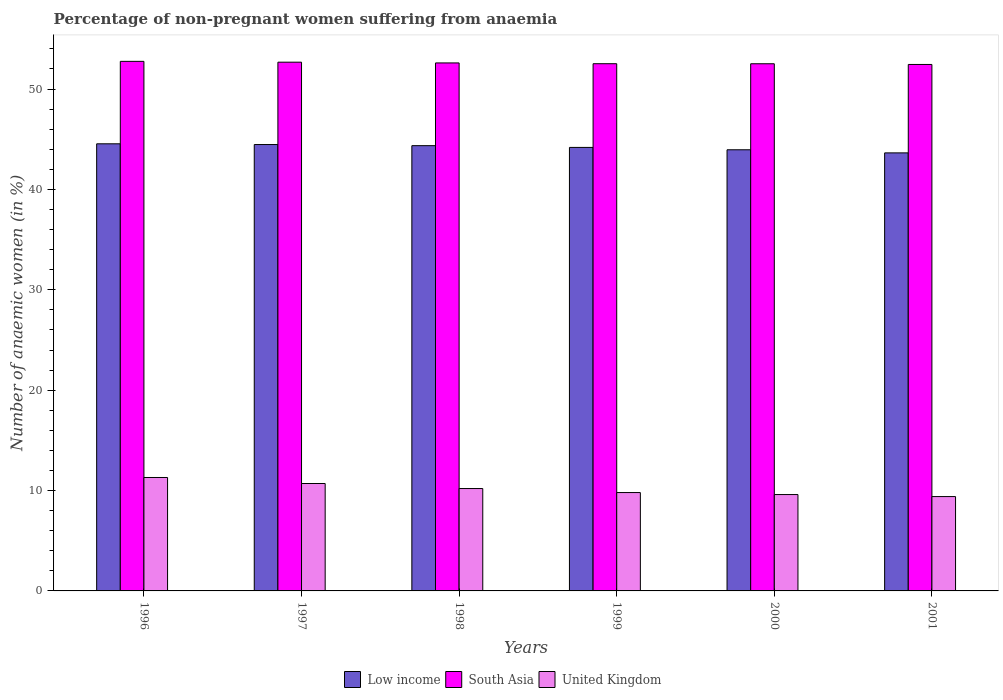How many different coloured bars are there?
Ensure brevity in your answer.  3. Are the number of bars per tick equal to the number of legend labels?
Offer a very short reply. Yes. How many bars are there on the 5th tick from the left?
Give a very brief answer. 3. What is the percentage of non-pregnant women suffering from anaemia in United Kingdom in 1996?
Offer a terse response. 11.3. Across all years, what is the maximum percentage of non-pregnant women suffering from anaemia in South Asia?
Your response must be concise. 52.76. In which year was the percentage of non-pregnant women suffering from anaemia in Low income minimum?
Make the answer very short. 2001. What is the difference between the percentage of non-pregnant women suffering from anaemia in South Asia in 1996 and that in 2001?
Offer a very short reply. 0.31. What is the difference between the percentage of non-pregnant women suffering from anaemia in Low income in 2000 and the percentage of non-pregnant women suffering from anaemia in United Kingdom in 2001?
Your answer should be compact. 34.55. What is the average percentage of non-pregnant women suffering from anaemia in Low income per year?
Provide a succinct answer. 44.19. In the year 1999, what is the difference between the percentage of non-pregnant women suffering from anaemia in Low income and percentage of non-pregnant women suffering from anaemia in South Asia?
Offer a very short reply. -8.34. In how many years, is the percentage of non-pregnant women suffering from anaemia in United Kingdom greater than 6 %?
Keep it short and to the point. 6. What is the ratio of the percentage of non-pregnant women suffering from anaemia in South Asia in 1997 to that in 2001?
Make the answer very short. 1. Is the percentage of non-pregnant women suffering from anaemia in United Kingdom in 1997 less than that in 1998?
Offer a very short reply. No. Is the difference between the percentage of non-pregnant women suffering from anaemia in Low income in 1997 and 1998 greater than the difference between the percentage of non-pregnant women suffering from anaemia in South Asia in 1997 and 1998?
Make the answer very short. Yes. What is the difference between the highest and the second highest percentage of non-pregnant women suffering from anaemia in South Asia?
Keep it short and to the point. 0.08. What is the difference between the highest and the lowest percentage of non-pregnant women suffering from anaemia in South Asia?
Your response must be concise. 0.31. In how many years, is the percentage of non-pregnant women suffering from anaemia in Low income greater than the average percentage of non-pregnant women suffering from anaemia in Low income taken over all years?
Your answer should be very brief. 3. Is the sum of the percentage of non-pregnant women suffering from anaemia in Low income in 1997 and 2000 greater than the maximum percentage of non-pregnant women suffering from anaemia in United Kingdom across all years?
Your response must be concise. Yes. Are all the bars in the graph horizontal?
Provide a short and direct response. No. Are the values on the major ticks of Y-axis written in scientific E-notation?
Your answer should be very brief. No. Does the graph contain any zero values?
Your response must be concise. No. How many legend labels are there?
Provide a succinct answer. 3. How are the legend labels stacked?
Your response must be concise. Horizontal. What is the title of the graph?
Offer a terse response. Percentage of non-pregnant women suffering from anaemia. Does "Ghana" appear as one of the legend labels in the graph?
Offer a very short reply. No. What is the label or title of the X-axis?
Ensure brevity in your answer.  Years. What is the label or title of the Y-axis?
Provide a succinct answer. Number of anaemic women (in %). What is the Number of anaemic women (in %) in Low income in 1996?
Your answer should be very brief. 44.54. What is the Number of anaemic women (in %) of South Asia in 1996?
Your response must be concise. 52.76. What is the Number of anaemic women (in %) of Low income in 1997?
Keep it short and to the point. 44.47. What is the Number of anaemic women (in %) of South Asia in 1997?
Your answer should be compact. 52.67. What is the Number of anaemic women (in %) of Low income in 1998?
Offer a terse response. 44.36. What is the Number of anaemic women (in %) in South Asia in 1998?
Keep it short and to the point. 52.6. What is the Number of anaemic women (in %) in United Kingdom in 1998?
Keep it short and to the point. 10.2. What is the Number of anaemic women (in %) in Low income in 1999?
Provide a short and direct response. 44.18. What is the Number of anaemic women (in %) in South Asia in 1999?
Ensure brevity in your answer.  52.52. What is the Number of anaemic women (in %) in United Kingdom in 1999?
Your answer should be compact. 9.8. What is the Number of anaemic women (in %) of Low income in 2000?
Your response must be concise. 43.95. What is the Number of anaemic women (in %) of South Asia in 2000?
Your answer should be compact. 52.52. What is the Number of anaemic women (in %) in United Kingdom in 2000?
Provide a succinct answer. 9.6. What is the Number of anaemic women (in %) of Low income in 2001?
Keep it short and to the point. 43.64. What is the Number of anaemic women (in %) in South Asia in 2001?
Your response must be concise. 52.45. What is the Number of anaemic women (in %) of United Kingdom in 2001?
Your response must be concise. 9.4. Across all years, what is the maximum Number of anaemic women (in %) of Low income?
Your answer should be very brief. 44.54. Across all years, what is the maximum Number of anaemic women (in %) of South Asia?
Provide a short and direct response. 52.76. Across all years, what is the minimum Number of anaemic women (in %) of Low income?
Your answer should be very brief. 43.64. Across all years, what is the minimum Number of anaemic women (in %) in South Asia?
Your answer should be very brief. 52.45. Across all years, what is the minimum Number of anaemic women (in %) of United Kingdom?
Ensure brevity in your answer.  9.4. What is the total Number of anaemic women (in %) in Low income in the graph?
Keep it short and to the point. 265.14. What is the total Number of anaemic women (in %) in South Asia in the graph?
Your answer should be very brief. 315.51. What is the total Number of anaemic women (in %) of United Kingdom in the graph?
Provide a short and direct response. 61. What is the difference between the Number of anaemic women (in %) of Low income in 1996 and that in 1997?
Provide a succinct answer. 0.07. What is the difference between the Number of anaemic women (in %) of South Asia in 1996 and that in 1997?
Keep it short and to the point. 0.08. What is the difference between the Number of anaemic women (in %) of Low income in 1996 and that in 1998?
Make the answer very short. 0.18. What is the difference between the Number of anaemic women (in %) in South Asia in 1996 and that in 1998?
Provide a short and direct response. 0.16. What is the difference between the Number of anaemic women (in %) of Low income in 1996 and that in 1999?
Your answer should be compact. 0.36. What is the difference between the Number of anaemic women (in %) of South Asia in 1996 and that in 1999?
Provide a short and direct response. 0.24. What is the difference between the Number of anaemic women (in %) in Low income in 1996 and that in 2000?
Make the answer very short. 0.59. What is the difference between the Number of anaemic women (in %) in South Asia in 1996 and that in 2000?
Offer a terse response. 0.24. What is the difference between the Number of anaemic women (in %) in Low income in 1996 and that in 2001?
Ensure brevity in your answer.  0.9. What is the difference between the Number of anaemic women (in %) of South Asia in 1996 and that in 2001?
Provide a short and direct response. 0.31. What is the difference between the Number of anaemic women (in %) in Low income in 1997 and that in 1998?
Your answer should be very brief. 0.11. What is the difference between the Number of anaemic women (in %) of South Asia in 1997 and that in 1998?
Provide a short and direct response. 0.07. What is the difference between the Number of anaemic women (in %) of United Kingdom in 1997 and that in 1998?
Provide a short and direct response. 0.5. What is the difference between the Number of anaemic women (in %) in Low income in 1997 and that in 1999?
Offer a terse response. 0.29. What is the difference between the Number of anaemic women (in %) in South Asia in 1997 and that in 1999?
Your answer should be very brief. 0.15. What is the difference between the Number of anaemic women (in %) of United Kingdom in 1997 and that in 1999?
Ensure brevity in your answer.  0.9. What is the difference between the Number of anaemic women (in %) in Low income in 1997 and that in 2000?
Ensure brevity in your answer.  0.52. What is the difference between the Number of anaemic women (in %) in South Asia in 1997 and that in 2000?
Provide a succinct answer. 0.16. What is the difference between the Number of anaemic women (in %) in Low income in 1997 and that in 2001?
Your answer should be very brief. 0.83. What is the difference between the Number of anaemic women (in %) in South Asia in 1997 and that in 2001?
Give a very brief answer. 0.23. What is the difference between the Number of anaemic women (in %) of Low income in 1998 and that in 1999?
Give a very brief answer. 0.17. What is the difference between the Number of anaemic women (in %) of South Asia in 1998 and that in 1999?
Ensure brevity in your answer.  0.08. What is the difference between the Number of anaemic women (in %) in Low income in 1998 and that in 2000?
Your answer should be compact. 0.41. What is the difference between the Number of anaemic women (in %) of South Asia in 1998 and that in 2000?
Give a very brief answer. 0.08. What is the difference between the Number of anaemic women (in %) in United Kingdom in 1998 and that in 2000?
Your response must be concise. 0.6. What is the difference between the Number of anaemic women (in %) of Low income in 1998 and that in 2001?
Your answer should be compact. 0.72. What is the difference between the Number of anaemic women (in %) of South Asia in 1998 and that in 2001?
Keep it short and to the point. 0.15. What is the difference between the Number of anaemic women (in %) in United Kingdom in 1998 and that in 2001?
Ensure brevity in your answer.  0.8. What is the difference between the Number of anaemic women (in %) of Low income in 1999 and that in 2000?
Offer a terse response. 0.24. What is the difference between the Number of anaemic women (in %) of South Asia in 1999 and that in 2000?
Your answer should be compact. 0. What is the difference between the Number of anaemic women (in %) of United Kingdom in 1999 and that in 2000?
Provide a short and direct response. 0.2. What is the difference between the Number of anaemic women (in %) of Low income in 1999 and that in 2001?
Your answer should be very brief. 0.54. What is the difference between the Number of anaemic women (in %) in South Asia in 1999 and that in 2001?
Provide a succinct answer. 0.07. What is the difference between the Number of anaemic women (in %) of United Kingdom in 1999 and that in 2001?
Provide a succinct answer. 0.4. What is the difference between the Number of anaemic women (in %) of Low income in 2000 and that in 2001?
Offer a terse response. 0.31. What is the difference between the Number of anaemic women (in %) of South Asia in 2000 and that in 2001?
Your answer should be compact. 0.07. What is the difference between the Number of anaemic women (in %) of United Kingdom in 2000 and that in 2001?
Ensure brevity in your answer.  0.2. What is the difference between the Number of anaemic women (in %) in Low income in 1996 and the Number of anaemic women (in %) in South Asia in 1997?
Make the answer very short. -8.13. What is the difference between the Number of anaemic women (in %) of Low income in 1996 and the Number of anaemic women (in %) of United Kingdom in 1997?
Your response must be concise. 33.84. What is the difference between the Number of anaemic women (in %) of South Asia in 1996 and the Number of anaemic women (in %) of United Kingdom in 1997?
Provide a succinct answer. 42.06. What is the difference between the Number of anaemic women (in %) in Low income in 1996 and the Number of anaemic women (in %) in South Asia in 1998?
Give a very brief answer. -8.06. What is the difference between the Number of anaemic women (in %) in Low income in 1996 and the Number of anaemic women (in %) in United Kingdom in 1998?
Keep it short and to the point. 34.34. What is the difference between the Number of anaemic women (in %) in South Asia in 1996 and the Number of anaemic women (in %) in United Kingdom in 1998?
Offer a very short reply. 42.56. What is the difference between the Number of anaemic women (in %) in Low income in 1996 and the Number of anaemic women (in %) in South Asia in 1999?
Offer a very short reply. -7.98. What is the difference between the Number of anaemic women (in %) in Low income in 1996 and the Number of anaemic women (in %) in United Kingdom in 1999?
Ensure brevity in your answer.  34.74. What is the difference between the Number of anaemic women (in %) of South Asia in 1996 and the Number of anaemic women (in %) of United Kingdom in 1999?
Provide a short and direct response. 42.96. What is the difference between the Number of anaemic women (in %) of Low income in 1996 and the Number of anaemic women (in %) of South Asia in 2000?
Provide a succinct answer. -7.97. What is the difference between the Number of anaemic women (in %) of Low income in 1996 and the Number of anaemic women (in %) of United Kingdom in 2000?
Give a very brief answer. 34.94. What is the difference between the Number of anaemic women (in %) in South Asia in 1996 and the Number of anaemic women (in %) in United Kingdom in 2000?
Provide a succinct answer. 43.16. What is the difference between the Number of anaemic women (in %) in Low income in 1996 and the Number of anaemic women (in %) in South Asia in 2001?
Your answer should be very brief. -7.9. What is the difference between the Number of anaemic women (in %) in Low income in 1996 and the Number of anaemic women (in %) in United Kingdom in 2001?
Keep it short and to the point. 35.14. What is the difference between the Number of anaemic women (in %) in South Asia in 1996 and the Number of anaemic women (in %) in United Kingdom in 2001?
Make the answer very short. 43.36. What is the difference between the Number of anaemic women (in %) in Low income in 1997 and the Number of anaemic women (in %) in South Asia in 1998?
Offer a terse response. -8.13. What is the difference between the Number of anaemic women (in %) of Low income in 1997 and the Number of anaemic women (in %) of United Kingdom in 1998?
Your answer should be very brief. 34.27. What is the difference between the Number of anaemic women (in %) of South Asia in 1997 and the Number of anaemic women (in %) of United Kingdom in 1998?
Offer a terse response. 42.47. What is the difference between the Number of anaemic women (in %) in Low income in 1997 and the Number of anaemic women (in %) in South Asia in 1999?
Offer a terse response. -8.05. What is the difference between the Number of anaemic women (in %) in Low income in 1997 and the Number of anaemic women (in %) in United Kingdom in 1999?
Your response must be concise. 34.67. What is the difference between the Number of anaemic women (in %) of South Asia in 1997 and the Number of anaemic women (in %) of United Kingdom in 1999?
Provide a succinct answer. 42.87. What is the difference between the Number of anaemic women (in %) of Low income in 1997 and the Number of anaemic women (in %) of South Asia in 2000?
Give a very brief answer. -8.05. What is the difference between the Number of anaemic women (in %) in Low income in 1997 and the Number of anaemic women (in %) in United Kingdom in 2000?
Give a very brief answer. 34.87. What is the difference between the Number of anaemic women (in %) in South Asia in 1997 and the Number of anaemic women (in %) in United Kingdom in 2000?
Your answer should be very brief. 43.07. What is the difference between the Number of anaemic women (in %) in Low income in 1997 and the Number of anaemic women (in %) in South Asia in 2001?
Ensure brevity in your answer.  -7.98. What is the difference between the Number of anaemic women (in %) of Low income in 1997 and the Number of anaemic women (in %) of United Kingdom in 2001?
Provide a succinct answer. 35.07. What is the difference between the Number of anaemic women (in %) in South Asia in 1997 and the Number of anaemic women (in %) in United Kingdom in 2001?
Provide a short and direct response. 43.27. What is the difference between the Number of anaemic women (in %) of Low income in 1998 and the Number of anaemic women (in %) of South Asia in 1999?
Offer a terse response. -8.16. What is the difference between the Number of anaemic women (in %) in Low income in 1998 and the Number of anaemic women (in %) in United Kingdom in 1999?
Offer a terse response. 34.56. What is the difference between the Number of anaemic women (in %) in South Asia in 1998 and the Number of anaemic women (in %) in United Kingdom in 1999?
Keep it short and to the point. 42.8. What is the difference between the Number of anaemic women (in %) in Low income in 1998 and the Number of anaemic women (in %) in South Asia in 2000?
Keep it short and to the point. -8.16. What is the difference between the Number of anaemic women (in %) in Low income in 1998 and the Number of anaemic women (in %) in United Kingdom in 2000?
Your response must be concise. 34.76. What is the difference between the Number of anaemic women (in %) in South Asia in 1998 and the Number of anaemic women (in %) in United Kingdom in 2000?
Provide a succinct answer. 43. What is the difference between the Number of anaemic women (in %) of Low income in 1998 and the Number of anaemic women (in %) of South Asia in 2001?
Keep it short and to the point. -8.09. What is the difference between the Number of anaemic women (in %) of Low income in 1998 and the Number of anaemic women (in %) of United Kingdom in 2001?
Give a very brief answer. 34.96. What is the difference between the Number of anaemic women (in %) in South Asia in 1998 and the Number of anaemic women (in %) in United Kingdom in 2001?
Provide a succinct answer. 43.2. What is the difference between the Number of anaemic women (in %) of Low income in 1999 and the Number of anaemic women (in %) of South Asia in 2000?
Ensure brevity in your answer.  -8.33. What is the difference between the Number of anaemic women (in %) of Low income in 1999 and the Number of anaemic women (in %) of United Kingdom in 2000?
Provide a short and direct response. 34.58. What is the difference between the Number of anaemic women (in %) in South Asia in 1999 and the Number of anaemic women (in %) in United Kingdom in 2000?
Keep it short and to the point. 42.92. What is the difference between the Number of anaemic women (in %) of Low income in 1999 and the Number of anaemic women (in %) of South Asia in 2001?
Give a very brief answer. -8.26. What is the difference between the Number of anaemic women (in %) of Low income in 1999 and the Number of anaemic women (in %) of United Kingdom in 2001?
Keep it short and to the point. 34.78. What is the difference between the Number of anaemic women (in %) in South Asia in 1999 and the Number of anaemic women (in %) in United Kingdom in 2001?
Give a very brief answer. 43.12. What is the difference between the Number of anaemic women (in %) in Low income in 2000 and the Number of anaemic women (in %) in South Asia in 2001?
Ensure brevity in your answer.  -8.5. What is the difference between the Number of anaemic women (in %) of Low income in 2000 and the Number of anaemic women (in %) of United Kingdom in 2001?
Offer a very short reply. 34.55. What is the difference between the Number of anaemic women (in %) of South Asia in 2000 and the Number of anaemic women (in %) of United Kingdom in 2001?
Provide a short and direct response. 43.12. What is the average Number of anaemic women (in %) in Low income per year?
Offer a very short reply. 44.19. What is the average Number of anaemic women (in %) of South Asia per year?
Provide a succinct answer. 52.59. What is the average Number of anaemic women (in %) in United Kingdom per year?
Offer a very short reply. 10.17. In the year 1996, what is the difference between the Number of anaemic women (in %) of Low income and Number of anaemic women (in %) of South Asia?
Your answer should be compact. -8.21. In the year 1996, what is the difference between the Number of anaemic women (in %) in Low income and Number of anaemic women (in %) in United Kingdom?
Offer a terse response. 33.24. In the year 1996, what is the difference between the Number of anaemic women (in %) of South Asia and Number of anaemic women (in %) of United Kingdom?
Keep it short and to the point. 41.46. In the year 1997, what is the difference between the Number of anaemic women (in %) in Low income and Number of anaemic women (in %) in South Asia?
Offer a terse response. -8.2. In the year 1997, what is the difference between the Number of anaemic women (in %) in Low income and Number of anaemic women (in %) in United Kingdom?
Ensure brevity in your answer.  33.77. In the year 1997, what is the difference between the Number of anaemic women (in %) in South Asia and Number of anaemic women (in %) in United Kingdom?
Your answer should be compact. 41.97. In the year 1998, what is the difference between the Number of anaemic women (in %) in Low income and Number of anaemic women (in %) in South Asia?
Provide a succinct answer. -8.24. In the year 1998, what is the difference between the Number of anaemic women (in %) in Low income and Number of anaemic women (in %) in United Kingdom?
Ensure brevity in your answer.  34.16. In the year 1998, what is the difference between the Number of anaemic women (in %) in South Asia and Number of anaemic women (in %) in United Kingdom?
Your answer should be compact. 42.4. In the year 1999, what is the difference between the Number of anaemic women (in %) in Low income and Number of anaemic women (in %) in South Asia?
Ensure brevity in your answer.  -8.34. In the year 1999, what is the difference between the Number of anaemic women (in %) in Low income and Number of anaemic women (in %) in United Kingdom?
Your answer should be compact. 34.38. In the year 1999, what is the difference between the Number of anaemic women (in %) in South Asia and Number of anaemic women (in %) in United Kingdom?
Ensure brevity in your answer.  42.72. In the year 2000, what is the difference between the Number of anaemic women (in %) in Low income and Number of anaemic women (in %) in South Asia?
Your answer should be very brief. -8.57. In the year 2000, what is the difference between the Number of anaemic women (in %) in Low income and Number of anaemic women (in %) in United Kingdom?
Your answer should be compact. 34.35. In the year 2000, what is the difference between the Number of anaemic women (in %) in South Asia and Number of anaemic women (in %) in United Kingdom?
Ensure brevity in your answer.  42.92. In the year 2001, what is the difference between the Number of anaemic women (in %) in Low income and Number of anaemic women (in %) in South Asia?
Keep it short and to the point. -8.81. In the year 2001, what is the difference between the Number of anaemic women (in %) in Low income and Number of anaemic women (in %) in United Kingdom?
Ensure brevity in your answer.  34.24. In the year 2001, what is the difference between the Number of anaemic women (in %) of South Asia and Number of anaemic women (in %) of United Kingdom?
Ensure brevity in your answer.  43.05. What is the ratio of the Number of anaemic women (in %) in Low income in 1996 to that in 1997?
Your answer should be very brief. 1. What is the ratio of the Number of anaemic women (in %) in South Asia in 1996 to that in 1997?
Ensure brevity in your answer.  1. What is the ratio of the Number of anaemic women (in %) of United Kingdom in 1996 to that in 1997?
Keep it short and to the point. 1.06. What is the ratio of the Number of anaemic women (in %) of Low income in 1996 to that in 1998?
Ensure brevity in your answer.  1. What is the ratio of the Number of anaemic women (in %) of South Asia in 1996 to that in 1998?
Offer a very short reply. 1. What is the ratio of the Number of anaemic women (in %) in United Kingdom in 1996 to that in 1998?
Offer a terse response. 1.11. What is the ratio of the Number of anaemic women (in %) in South Asia in 1996 to that in 1999?
Your answer should be compact. 1. What is the ratio of the Number of anaemic women (in %) of United Kingdom in 1996 to that in 1999?
Keep it short and to the point. 1.15. What is the ratio of the Number of anaemic women (in %) of Low income in 1996 to that in 2000?
Offer a very short reply. 1.01. What is the ratio of the Number of anaemic women (in %) of South Asia in 1996 to that in 2000?
Your answer should be compact. 1. What is the ratio of the Number of anaemic women (in %) in United Kingdom in 1996 to that in 2000?
Your response must be concise. 1.18. What is the ratio of the Number of anaemic women (in %) of Low income in 1996 to that in 2001?
Offer a terse response. 1.02. What is the ratio of the Number of anaemic women (in %) in South Asia in 1996 to that in 2001?
Your response must be concise. 1.01. What is the ratio of the Number of anaemic women (in %) of United Kingdom in 1996 to that in 2001?
Offer a very short reply. 1.2. What is the ratio of the Number of anaemic women (in %) of Low income in 1997 to that in 1998?
Your answer should be very brief. 1. What is the ratio of the Number of anaemic women (in %) in United Kingdom in 1997 to that in 1998?
Offer a terse response. 1.05. What is the ratio of the Number of anaemic women (in %) in Low income in 1997 to that in 1999?
Your answer should be very brief. 1.01. What is the ratio of the Number of anaemic women (in %) in South Asia in 1997 to that in 1999?
Your answer should be very brief. 1. What is the ratio of the Number of anaemic women (in %) in United Kingdom in 1997 to that in 1999?
Provide a short and direct response. 1.09. What is the ratio of the Number of anaemic women (in %) of Low income in 1997 to that in 2000?
Your answer should be compact. 1.01. What is the ratio of the Number of anaemic women (in %) of South Asia in 1997 to that in 2000?
Give a very brief answer. 1. What is the ratio of the Number of anaemic women (in %) of United Kingdom in 1997 to that in 2000?
Offer a terse response. 1.11. What is the ratio of the Number of anaemic women (in %) of Low income in 1997 to that in 2001?
Give a very brief answer. 1.02. What is the ratio of the Number of anaemic women (in %) in United Kingdom in 1997 to that in 2001?
Offer a very short reply. 1.14. What is the ratio of the Number of anaemic women (in %) of Low income in 1998 to that in 1999?
Give a very brief answer. 1. What is the ratio of the Number of anaemic women (in %) in South Asia in 1998 to that in 1999?
Make the answer very short. 1. What is the ratio of the Number of anaemic women (in %) in United Kingdom in 1998 to that in 1999?
Offer a terse response. 1.04. What is the ratio of the Number of anaemic women (in %) of Low income in 1998 to that in 2000?
Offer a terse response. 1.01. What is the ratio of the Number of anaemic women (in %) in Low income in 1998 to that in 2001?
Offer a very short reply. 1.02. What is the ratio of the Number of anaemic women (in %) of United Kingdom in 1998 to that in 2001?
Offer a very short reply. 1.09. What is the ratio of the Number of anaemic women (in %) of Low income in 1999 to that in 2000?
Make the answer very short. 1.01. What is the ratio of the Number of anaemic women (in %) in South Asia in 1999 to that in 2000?
Provide a short and direct response. 1. What is the ratio of the Number of anaemic women (in %) in United Kingdom in 1999 to that in 2000?
Give a very brief answer. 1.02. What is the ratio of the Number of anaemic women (in %) in Low income in 1999 to that in 2001?
Provide a short and direct response. 1.01. What is the ratio of the Number of anaemic women (in %) of South Asia in 1999 to that in 2001?
Provide a short and direct response. 1. What is the ratio of the Number of anaemic women (in %) in United Kingdom in 1999 to that in 2001?
Make the answer very short. 1.04. What is the ratio of the Number of anaemic women (in %) in Low income in 2000 to that in 2001?
Provide a succinct answer. 1.01. What is the ratio of the Number of anaemic women (in %) of United Kingdom in 2000 to that in 2001?
Provide a succinct answer. 1.02. What is the difference between the highest and the second highest Number of anaemic women (in %) of Low income?
Ensure brevity in your answer.  0.07. What is the difference between the highest and the second highest Number of anaemic women (in %) of South Asia?
Provide a succinct answer. 0.08. What is the difference between the highest and the second highest Number of anaemic women (in %) of United Kingdom?
Your response must be concise. 0.6. What is the difference between the highest and the lowest Number of anaemic women (in %) of Low income?
Provide a succinct answer. 0.9. What is the difference between the highest and the lowest Number of anaemic women (in %) in South Asia?
Offer a very short reply. 0.31. 